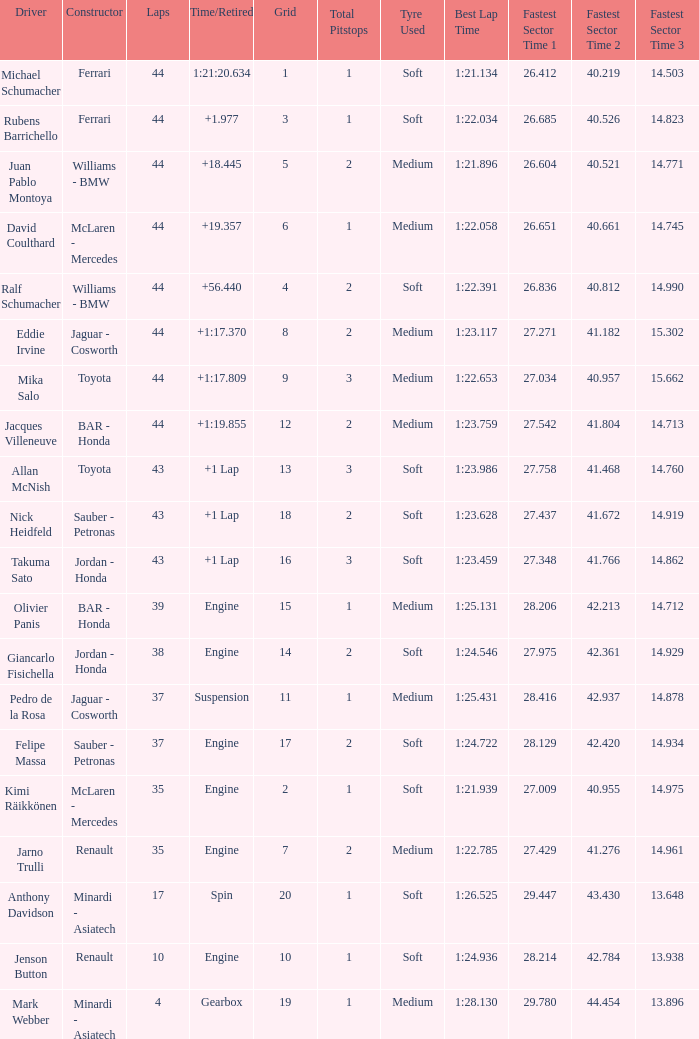Parse the full table. {'header': ['Driver', 'Constructor', 'Laps', 'Time/Retired', 'Grid', 'Total Pitstops', 'Tyre Used', 'Best Lap Time', 'Fastest Sector Time 1', 'Fastest Sector Time 2', 'Fastest Sector Time 3'], 'rows': [['Michael Schumacher', 'Ferrari', '44', '1:21:20.634', '1', '1', 'Soft', '1:21.134', '26.412', '40.219', '14.503'], ['Rubens Barrichello', 'Ferrari', '44', '+1.977', '3', '1', 'Soft', '1:22.034', '26.685', '40.526', '14.823'], ['Juan Pablo Montoya', 'Williams - BMW', '44', '+18.445', '5', '2', 'Medium', '1:21.896', '26.604', '40.521', '14.771'], ['David Coulthard', 'McLaren - Mercedes', '44', '+19.357', '6', '1', 'Medium', '1:22.058', '26.651', '40.661', '14.745'], ['Ralf Schumacher', 'Williams - BMW', '44', '+56.440', '4', '2', 'Soft', '1:22.391', '26.836', '40.812', '14.990'], ['Eddie Irvine', 'Jaguar - Cosworth', '44', '+1:17.370', '8', '2', 'Medium', '1:23.117', '27.271', '41.182', '15.302'], ['Mika Salo', 'Toyota', '44', '+1:17.809', '9', '3', 'Medium', '1:22.653', '27.034', '40.957', '15.662'], ['Jacques Villeneuve', 'BAR - Honda', '44', '+1:19.855', '12', '2', 'Medium', '1:23.759', '27.542', '41.804', '14.713'], ['Allan McNish', 'Toyota', '43', '+1 Lap', '13', '3', 'Soft', '1:23.986', '27.758', '41.468', '14.760'], ['Nick Heidfeld', 'Sauber - Petronas', '43', '+1 Lap', '18', '2', 'Soft', '1:23.628', '27.437', '41.672', '14.919'], ['Takuma Sato', 'Jordan - Honda', '43', '+1 Lap', '16', '3', 'Soft', '1:23.459', '27.348', '41.766', '14.862'], ['Olivier Panis', 'BAR - Honda', '39', 'Engine', '15', '1', 'Medium', '1:25.131', '28.206', '42.213', '14.712'], ['Giancarlo Fisichella', 'Jordan - Honda', '38', 'Engine', '14', '2', 'Soft', '1:24.546', '27.975', '42.361', '14.929'], ['Pedro de la Rosa', 'Jaguar - Cosworth', '37', 'Suspension', '11', '1', 'Medium', '1:25.431', '28.416', '42.937', '14.878'], ['Felipe Massa', 'Sauber - Petronas', '37', 'Engine', '17', '2', 'Soft', '1:24.722', '28.129', '42.420', '14.934'], ['Kimi Räikkönen', 'McLaren - Mercedes', '35', 'Engine', '2', '1', 'Soft', '1:21.939', '27.009', '40.955', '14.975'], ['Jarno Trulli', 'Renault', '35', 'Engine', '7', '2', 'Medium', '1:22.785', '27.429', '41.276', '14.961'], ['Anthony Davidson', 'Minardi - Asiatech', '17', 'Spin', '20', '1', 'Soft', '1:26.525', '29.447', '43.430', '13.648'], ['Jenson Button', 'Renault', '10', 'Engine', '10', '1', 'Soft', '1:24.936', '28.214', '42.784', '13.938'], ['Mark Webber', 'Minardi - Asiatech', '4', 'Gearbox', '19', '1', 'Medium', '1:28.130', '29.780', '44.454', '13.896']]} What was the retired time on someone who had 43 laps on a grip of 18? +1 Lap. 